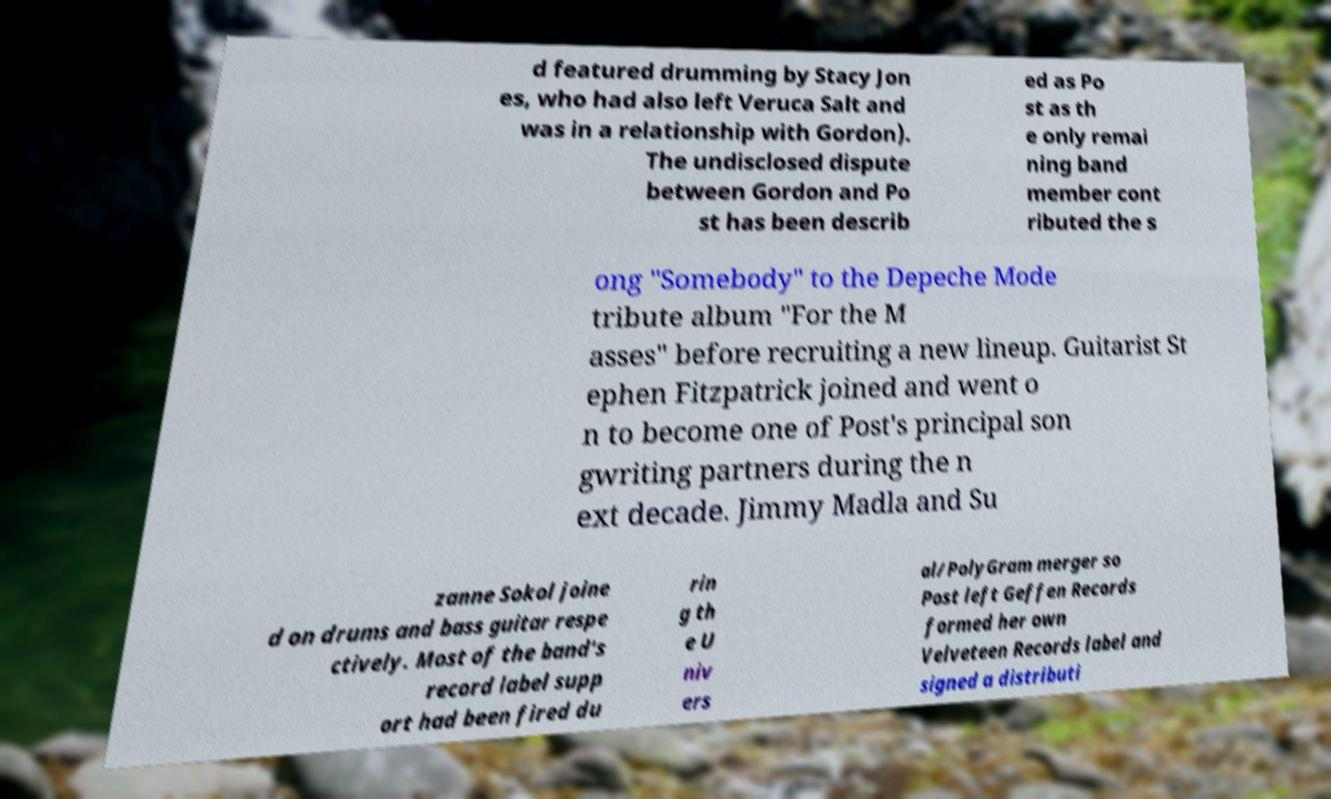Could you extract and type out the text from this image? d featured drumming by Stacy Jon es, who had also left Veruca Salt and was in a relationship with Gordon). The undisclosed dispute between Gordon and Po st has been describ ed as Po st as th e only remai ning band member cont ributed the s ong "Somebody" to the Depeche Mode tribute album "For the M asses" before recruiting a new lineup. Guitarist St ephen Fitzpatrick joined and went o n to become one of Post's principal son gwriting partners during the n ext decade. Jimmy Madla and Su zanne Sokol joine d on drums and bass guitar respe ctively. Most of the band's record label supp ort had been fired du rin g th e U niv ers al/PolyGram merger so Post left Geffen Records formed her own Velveteen Records label and signed a distributi 